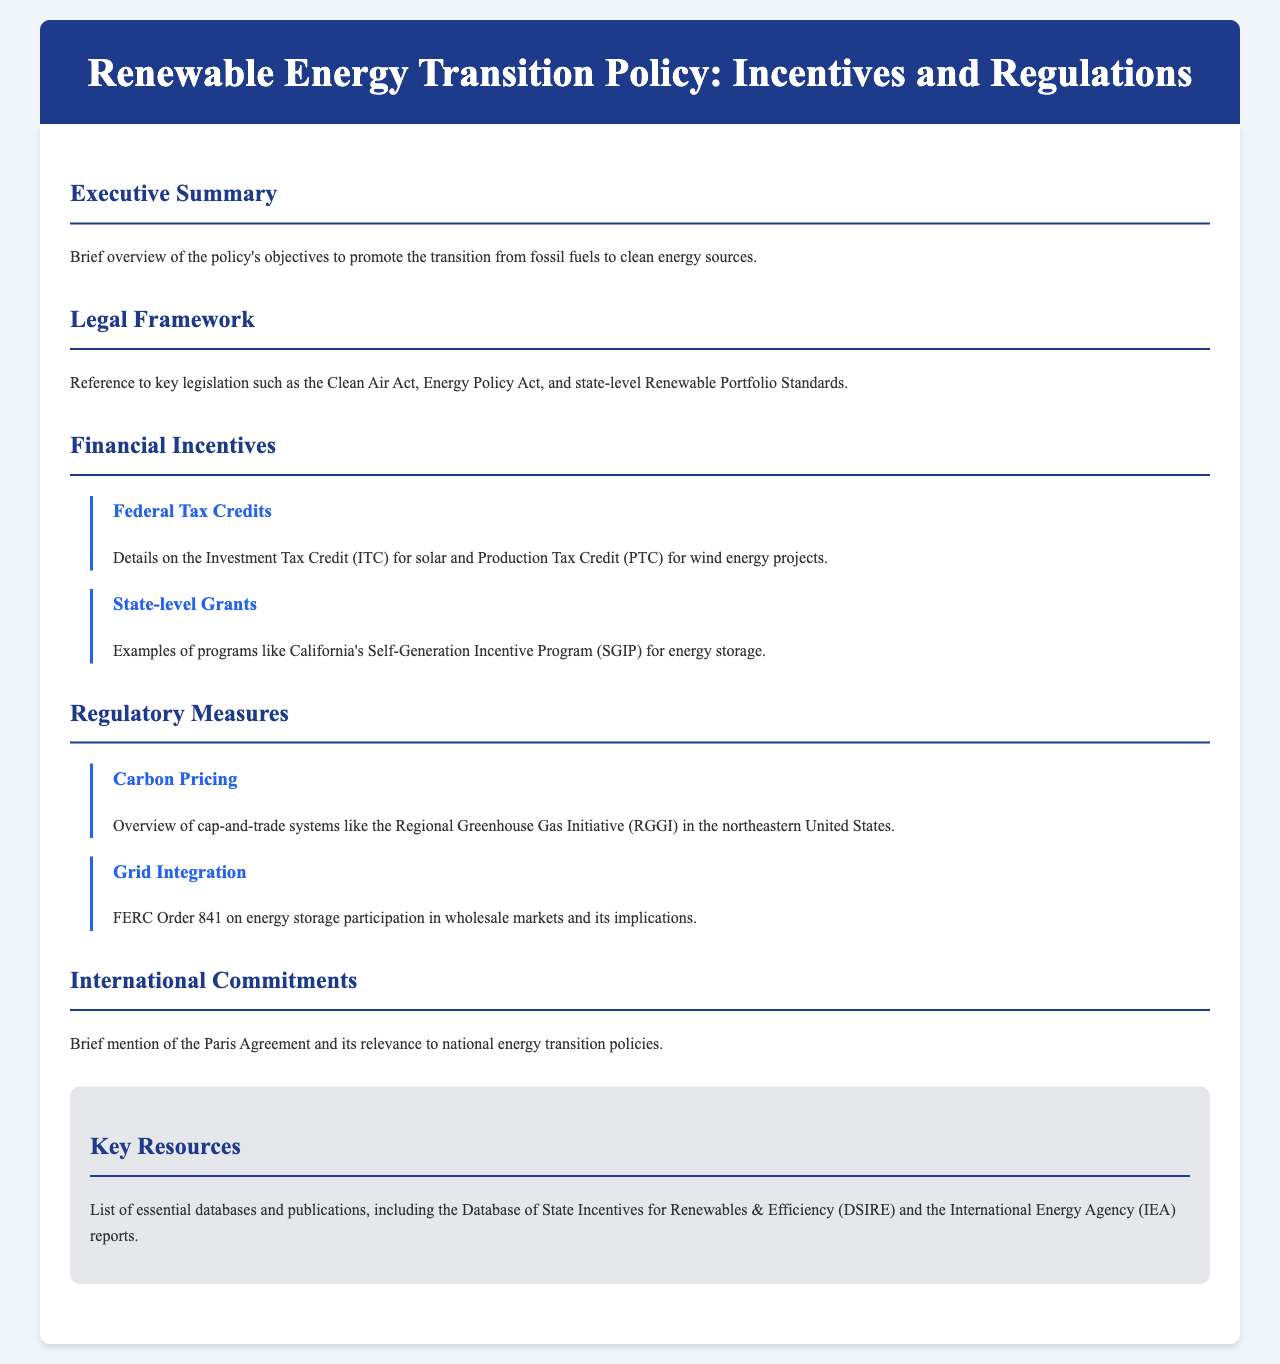What is the purpose of the policy? The policy aims to promote the transition from fossil fuels to clean energy sources.
Answer: promote the transition from fossil fuels to clean energy sources Which legislation is referenced in the legal framework? Key legislation includes the Clean Air Act and Energy Policy Act.
Answer: Clean Air Act, Energy Policy Act What is the Investment Tax Credit related to? The Investment Tax Credit (ITC) is related to solar energy projects.
Answer: solar energy projects What program does California's SGIP support? California's SGIP supports energy storage initiatives.
Answer: energy storage What system is mentioned under Carbon Pricing? The Regional Greenhouse Gas Initiative is mentioned under Carbon Pricing.
Answer: Regional Greenhouse Gas Initiative What does FERC Order 841 relate to? FERC Order 841 relates to energy storage participation in wholesale markets.
Answer: energy storage participation in wholesale markets Which international agreement is referenced in the document? The Paris Agreement is mentioned as relevant to national energy transition policies.
Answer: Paris Agreement What database is listed among the key resources? The Database of State Incentives for Renewables & Efficiency is listed.
Answer: Database of State Incentives for Renewables & Efficiency How many sections are there in total in the content? The document has six main sections: Executive Summary, Legal Framework, Financial Incentives, Regulatory Measures, International Commitments, and Key Resources.
Answer: six main sections 